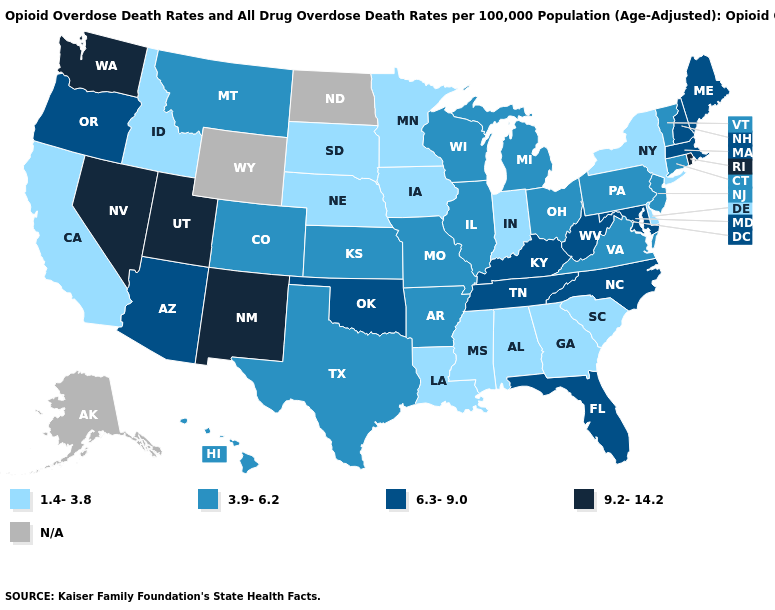Among the states that border North Dakota , which have the highest value?
Write a very short answer. Montana. Does Louisiana have the lowest value in the USA?
Short answer required. Yes. Which states have the lowest value in the USA?
Short answer required. Alabama, California, Delaware, Georgia, Idaho, Indiana, Iowa, Louisiana, Minnesota, Mississippi, Nebraska, New York, South Carolina, South Dakota. Among the states that border Minnesota , does Iowa have the lowest value?
Write a very short answer. Yes. How many symbols are there in the legend?
Short answer required. 5. Name the states that have a value in the range 1.4-3.8?
Answer briefly. Alabama, California, Delaware, Georgia, Idaho, Indiana, Iowa, Louisiana, Minnesota, Mississippi, Nebraska, New York, South Carolina, South Dakota. Among the states that border Tennessee , which have the lowest value?
Answer briefly. Alabama, Georgia, Mississippi. Name the states that have a value in the range 1.4-3.8?
Quick response, please. Alabama, California, Delaware, Georgia, Idaho, Indiana, Iowa, Louisiana, Minnesota, Mississippi, Nebraska, New York, South Carolina, South Dakota. What is the value of Maine?
Write a very short answer. 6.3-9.0. Is the legend a continuous bar?
Concise answer only. No. What is the value of Nebraska?
Be succinct. 1.4-3.8. Name the states that have a value in the range 3.9-6.2?
Be succinct. Arkansas, Colorado, Connecticut, Hawaii, Illinois, Kansas, Michigan, Missouri, Montana, New Jersey, Ohio, Pennsylvania, Texas, Vermont, Virginia, Wisconsin. What is the highest value in the MidWest ?
Write a very short answer. 3.9-6.2. 